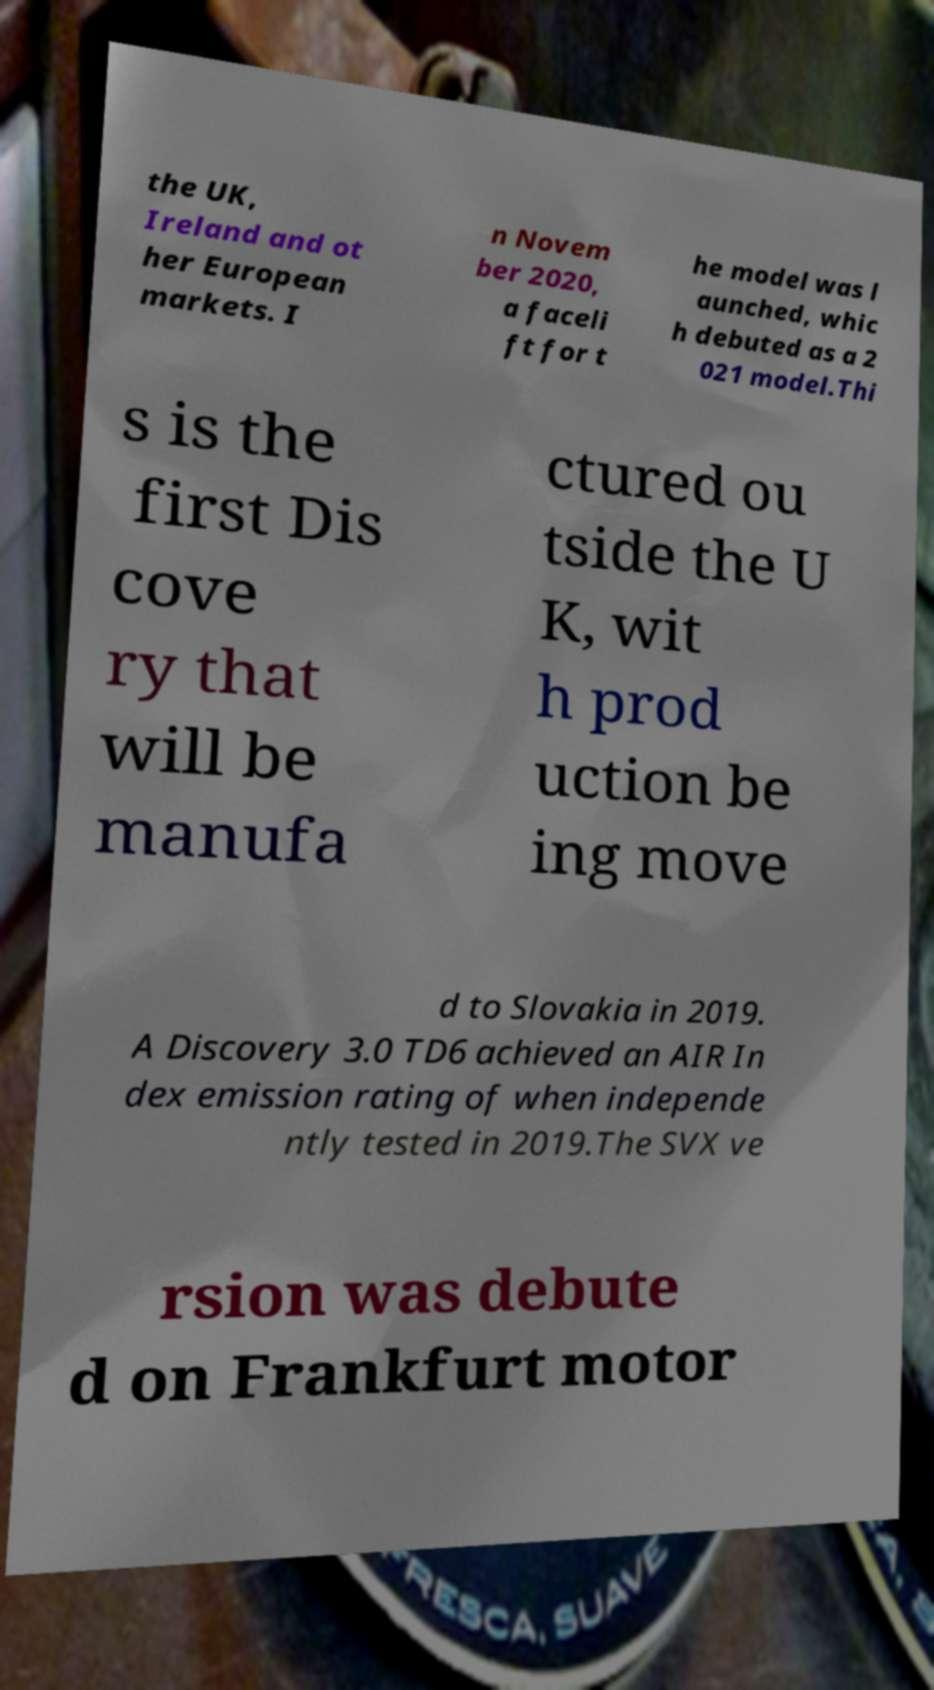Please identify and transcribe the text found in this image. the UK, Ireland and ot her European markets. I n Novem ber 2020, a faceli ft for t he model was l aunched, whic h debuted as a 2 021 model.Thi s is the first Dis cove ry that will be manufa ctured ou tside the U K, wit h prod uction be ing move d to Slovakia in 2019. A Discovery 3.0 TD6 achieved an AIR In dex emission rating of when independe ntly tested in 2019.The SVX ve rsion was debute d on Frankfurt motor 